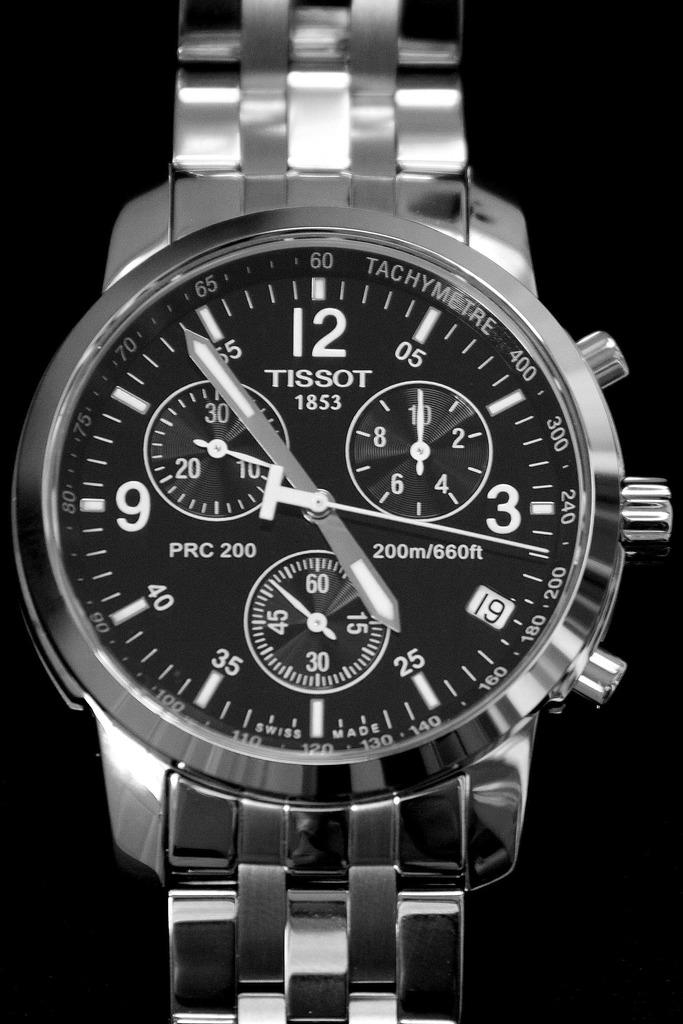<image>
Provide a brief description of the given image. Silver and black Tissot 1853 watch that is swiss made 